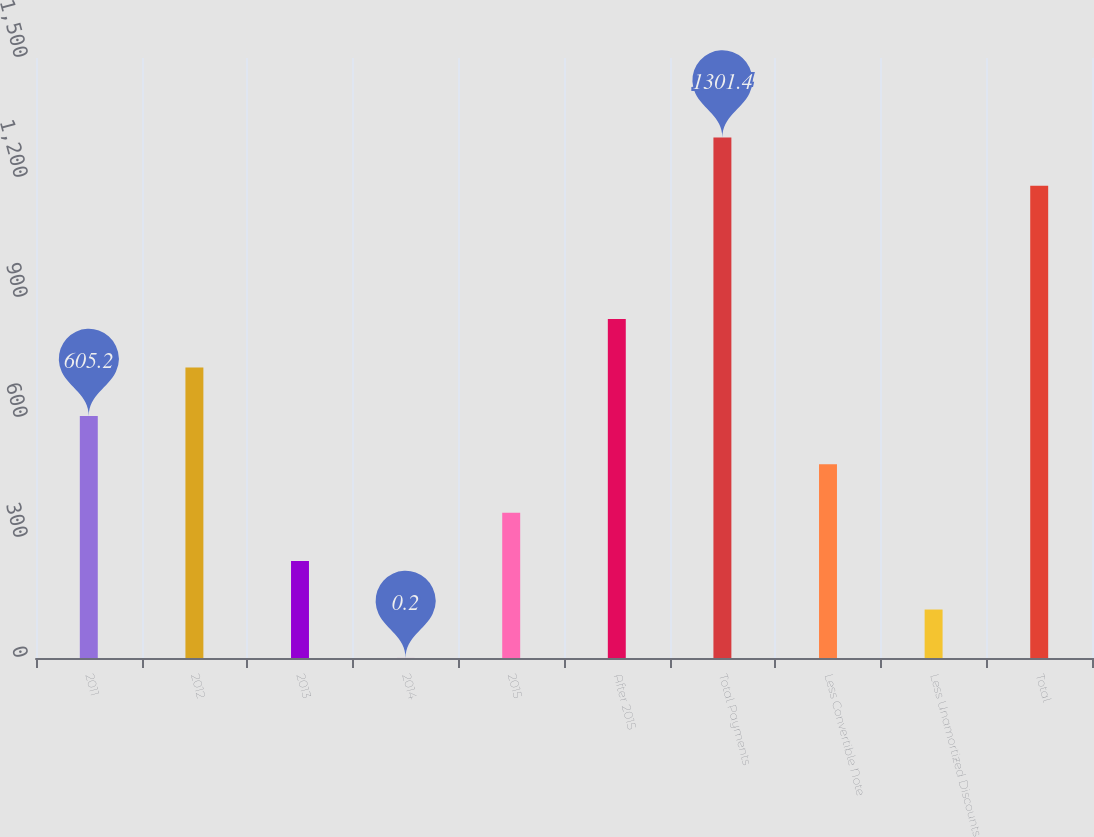<chart> <loc_0><loc_0><loc_500><loc_500><bar_chart><fcel>2011<fcel>2012<fcel>2013<fcel>2014<fcel>2015<fcel>After 2015<fcel>Total Payments<fcel>Less Convertible Note<fcel>Less Unamortized Discounts<fcel>Total<nl><fcel>605.2<fcel>726.2<fcel>242.2<fcel>0.2<fcel>363.2<fcel>847.2<fcel>1301.4<fcel>484.2<fcel>121.2<fcel>1180.4<nl></chart> 